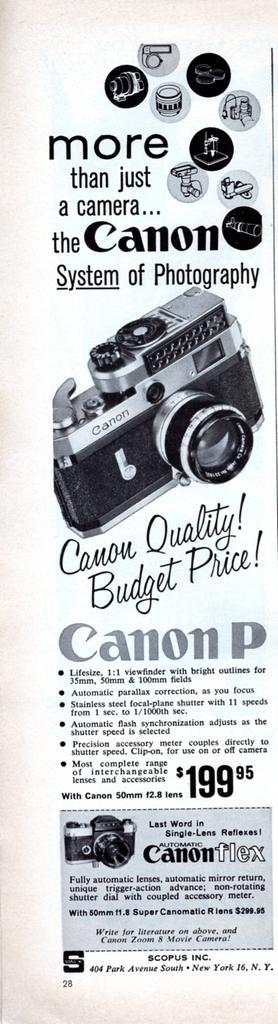In one or two sentences, can you explain what this image depicts? In the foreground of this poster, there is text and the cameras. 